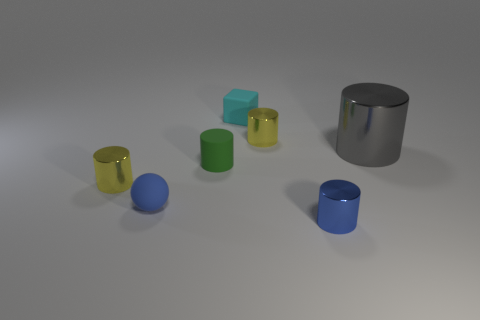How many gray objects are either tiny metallic things or big cylinders?
Offer a very short reply. 1. Is there a blue rubber sphere that has the same size as the gray metal cylinder?
Make the answer very short. No. What is the material of the blue cylinder that is the same size as the blue ball?
Your answer should be compact. Metal. Is the size of the yellow cylinder that is behind the big gray shiny cylinder the same as the metallic cylinder that is to the right of the small blue metal cylinder?
Make the answer very short. No. What number of things are either small objects or small yellow metallic objects on the left side of the cyan cube?
Your response must be concise. 6. Is there another matte object that has the same shape as the small cyan rubber thing?
Ensure brevity in your answer.  No. How big is the yellow thing to the left of the tiny shiny cylinder behind the tiny green cylinder?
Offer a terse response. Small. Does the big metallic cylinder have the same color as the matte cube?
Provide a short and direct response. No. How many metal things are either small cylinders or small yellow objects?
Offer a very short reply. 3. What number of yellow matte cylinders are there?
Your response must be concise. 0. 